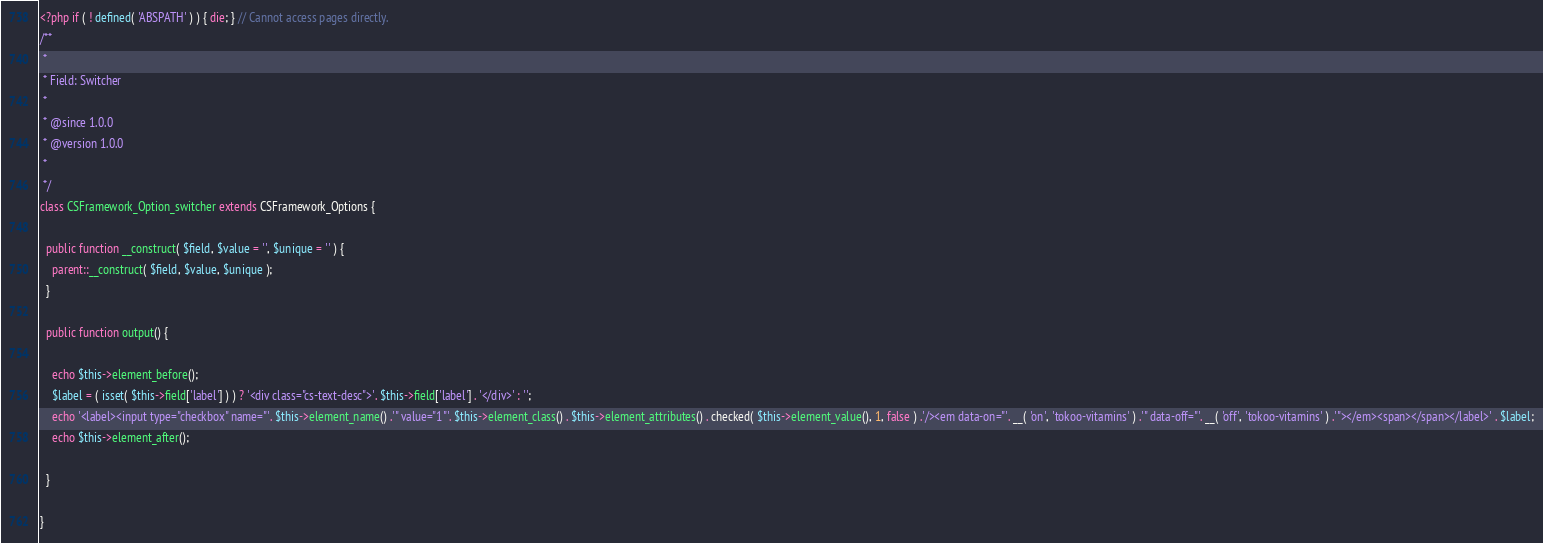Convert code to text. <code><loc_0><loc_0><loc_500><loc_500><_PHP_><?php if ( ! defined( 'ABSPATH' ) ) { die; } // Cannot access pages directly.
/**
 *
 * Field: Switcher
 *
 * @since 1.0.0
 * @version 1.0.0
 *
 */
class CSFramework_Option_switcher extends CSFramework_Options {

  public function __construct( $field, $value = '', $unique = '' ) {
    parent::__construct( $field, $value, $unique );
  }

  public function output() {

    echo $this->element_before();
    $label = ( isset( $this->field['label'] ) ) ? '<div class="cs-text-desc">'. $this->field['label'] . '</div>' : '';
    echo '<label><input type="checkbox" name="'. $this->element_name() .'" value="1"'. $this->element_class() . $this->element_attributes() . checked( $this->element_value(), 1, false ) .'/><em data-on="'. __( 'on', 'tokoo-vitamins' ) .'" data-off="'. __( 'off', 'tokoo-vitamins' ) .'"></em><span></span></label>' . $label;
    echo $this->element_after();

  }

}
</code> 